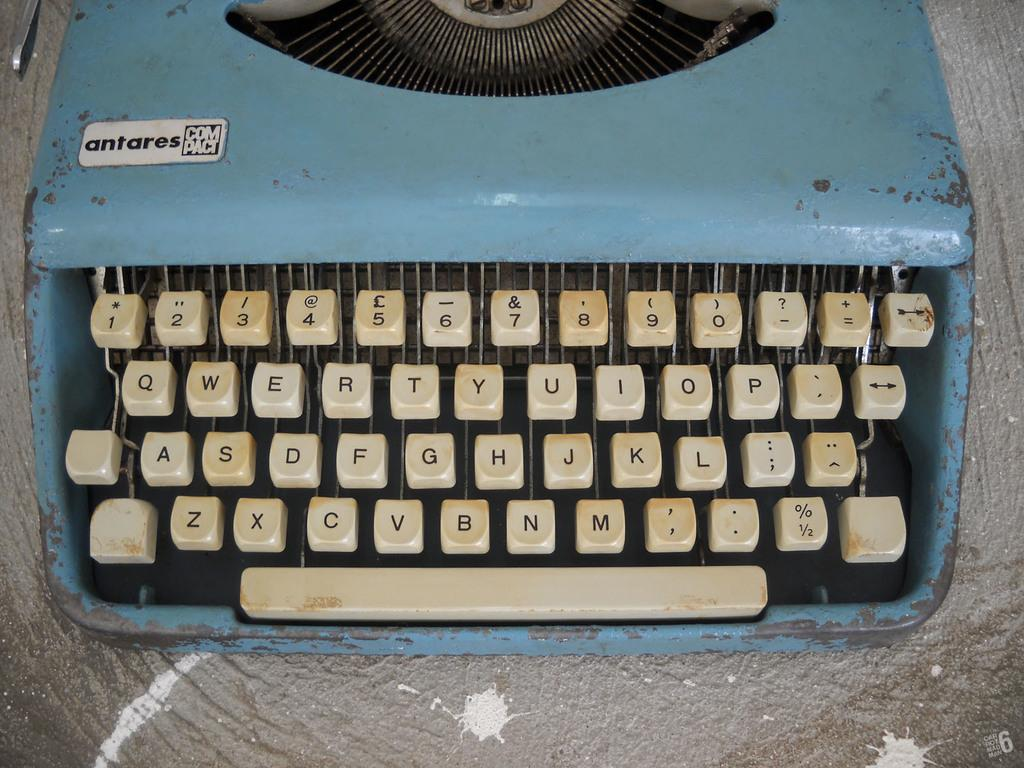Provide a one-sentence caption for the provided image. An old blue Antares compact typewriter looks like it needs to be cleaned. 